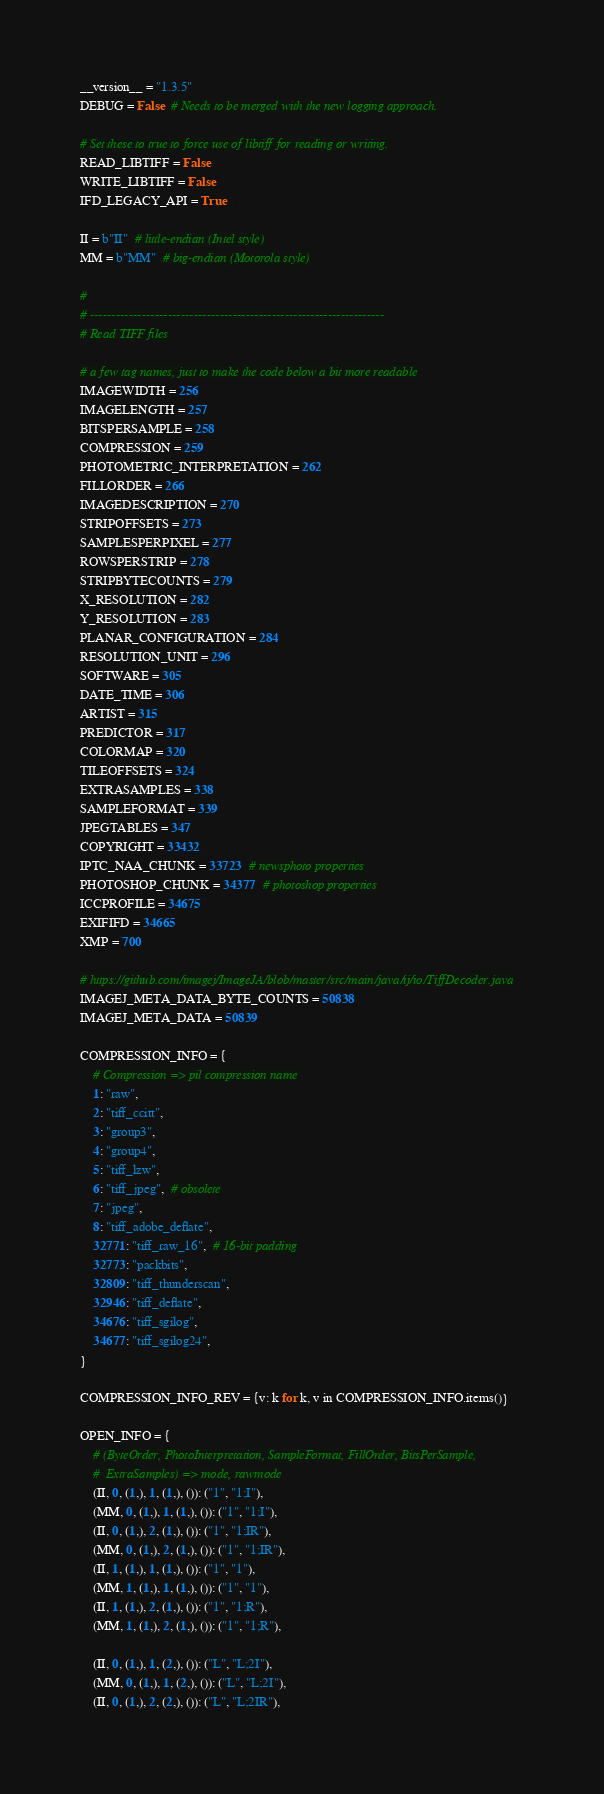Convert code to text. <code><loc_0><loc_0><loc_500><loc_500><_Python_>
__version__ = "1.3.5"
DEBUG = False  # Needs to be merged with the new logging approach.

# Set these to true to force use of libtiff for reading or writing.
READ_LIBTIFF = False
WRITE_LIBTIFF = False
IFD_LEGACY_API = True

II = b"II"  # little-endian (Intel style)
MM = b"MM"  # big-endian (Motorola style)

#
# --------------------------------------------------------------------
# Read TIFF files

# a few tag names, just to make the code below a bit more readable
IMAGEWIDTH = 256
IMAGELENGTH = 257
BITSPERSAMPLE = 258
COMPRESSION = 259
PHOTOMETRIC_INTERPRETATION = 262
FILLORDER = 266
IMAGEDESCRIPTION = 270
STRIPOFFSETS = 273
SAMPLESPERPIXEL = 277
ROWSPERSTRIP = 278
STRIPBYTECOUNTS = 279
X_RESOLUTION = 282
Y_RESOLUTION = 283
PLANAR_CONFIGURATION = 284
RESOLUTION_UNIT = 296
SOFTWARE = 305
DATE_TIME = 306
ARTIST = 315
PREDICTOR = 317
COLORMAP = 320
TILEOFFSETS = 324
EXTRASAMPLES = 338
SAMPLEFORMAT = 339
JPEGTABLES = 347
COPYRIGHT = 33432
IPTC_NAA_CHUNK = 33723  # newsphoto properties
PHOTOSHOP_CHUNK = 34377  # photoshop properties
ICCPROFILE = 34675
EXIFIFD = 34665
XMP = 700

# https://github.com/imagej/ImageJA/blob/master/src/main/java/ij/io/TiffDecoder.java
IMAGEJ_META_DATA_BYTE_COUNTS = 50838
IMAGEJ_META_DATA = 50839

COMPRESSION_INFO = {
    # Compression => pil compression name
    1: "raw",
    2: "tiff_ccitt",
    3: "group3",
    4: "group4",
    5: "tiff_lzw",
    6: "tiff_jpeg",  # obsolete
    7: "jpeg",
    8: "tiff_adobe_deflate",
    32771: "tiff_raw_16",  # 16-bit padding
    32773: "packbits",
    32809: "tiff_thunderscan",
    32946: "tiff_deflate",
    34676: "tiff_sgilog",
    34677: "tiff_sgilog24",
}

COMPRESSION_INFO_REV = {v: k for k, v in COMPRESSION_INFO.items()}

OPEN_INFO = {
    # (ByteOrder, PhotoInterpretation, SampleFormat, FillOrder, BitsPerSample,
    #  ExtraSamples) => mode, rawmode
    (II, 0, (1,), 1, (1,), ()): ("1", "1;I"),
    (MM, 0, (1,), 1, (1,), ()): ("1", "1;I"),
    (II, 0, (1,), 2, (1,), ()): ("1", "1;IR"),
    (MM, 0, (1,), 2, (1,), ()): ("1", "1;IR"),
    (II, 1, (1,), 1, (1,), ()): ("1", "1"),
    (MM, 1, (1,), 1, (1,), ()): ("1", "1"),
    (II, 1, (1,), 2, (1,), ()): ("1", "1;R"),
    (MM, 1, (1,), 2, (1,), ()): ("1", "1;R"),

    (II, 0, (1,), 1, (2,), ()): ("L", "L;2I"),
    (MM, 0, (1,), 1, (2,), ()): ("L", "L;2I"),
    (II, 0, (1,), 2, (2,), ()): ("L", "L;2IR"),</code> 